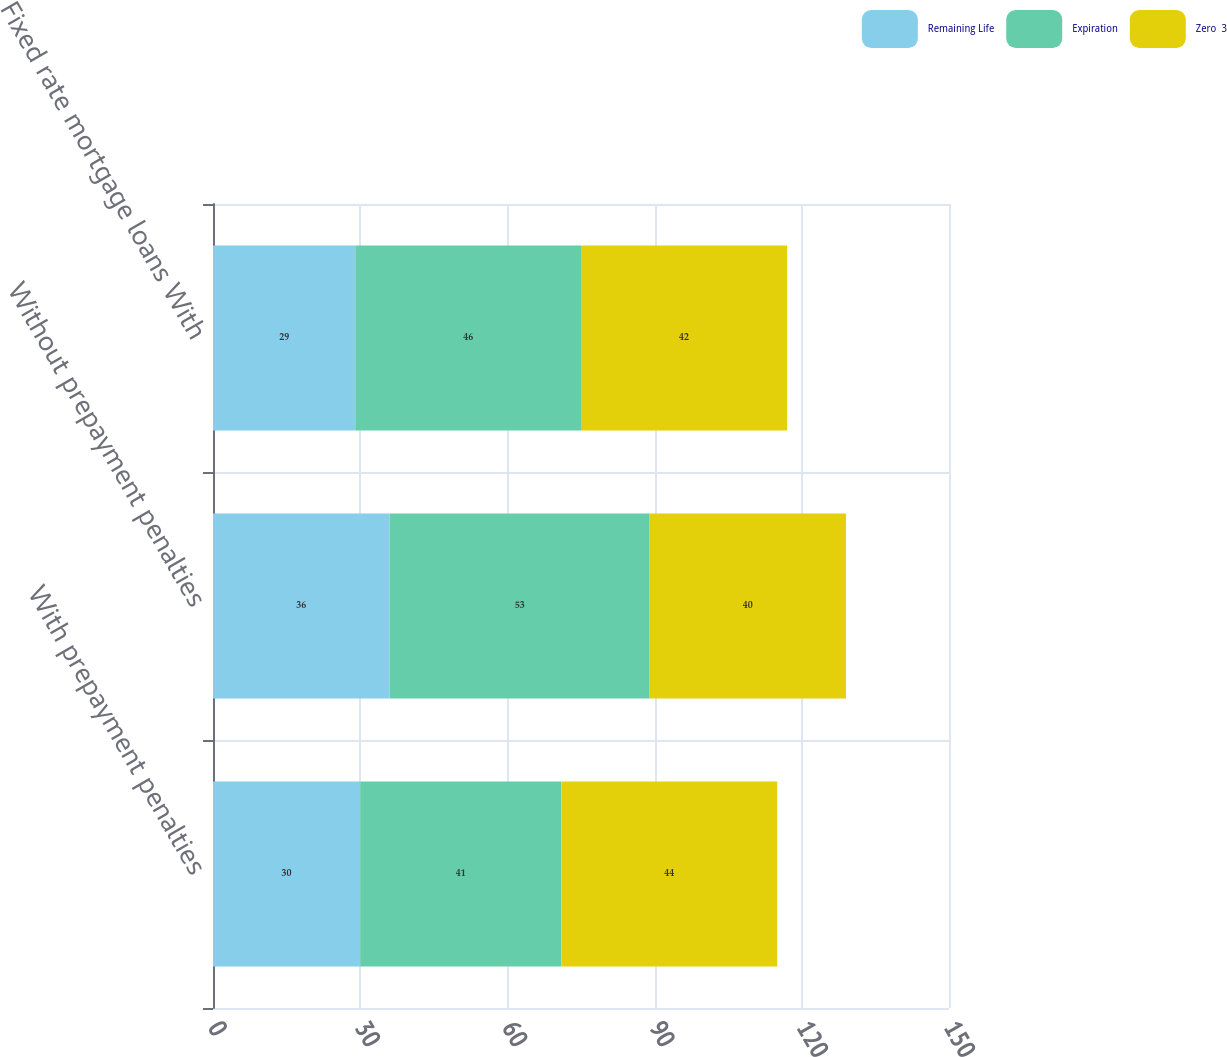Convert chart. <chart><loc_0><loc_0><loc_500><loc_500><stacked_bar_chart><ecel><fcel>With prepayment penalties<fcel>Without prepayment penalties<fcel>Fixed rate mortgage loans With<nl><fcel>Remaining Life<fcel>30<fcel>36<fcel>29<nl><fcel>Expiration<fcel>41<fcel>53<fcel>46<nl><fcel>Zero  3<fcel>44<fcel>40<fcel>42<nl></chart> 